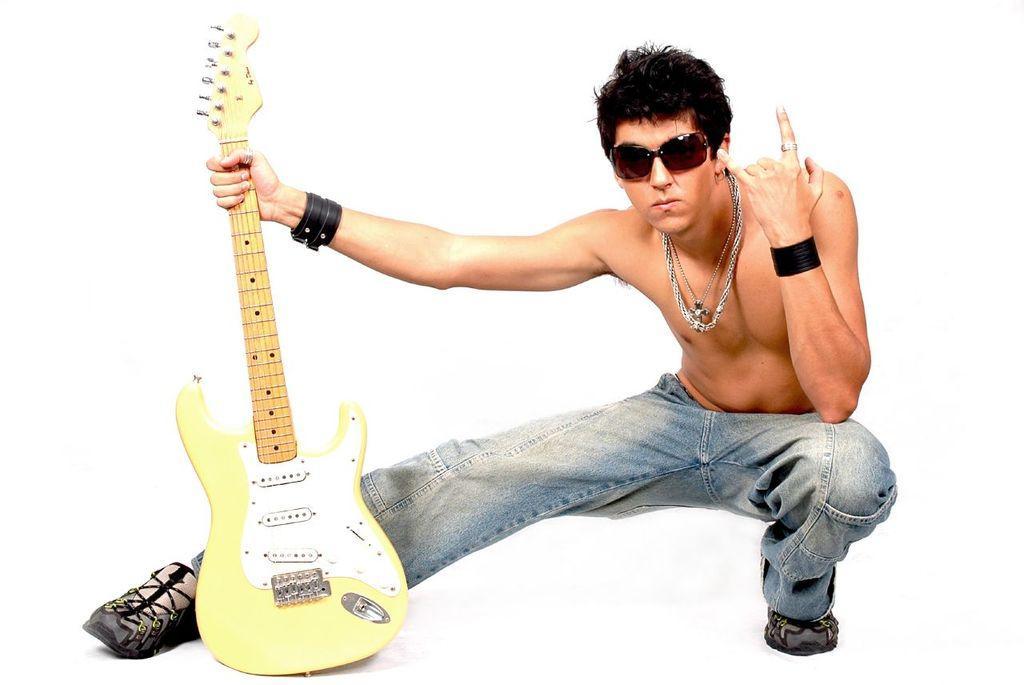Can you describe this image briefly? In this picture we can see a man wearing goggles, wrist band and chain and giving a different pose to the camera , holding a guitar in his hand. 